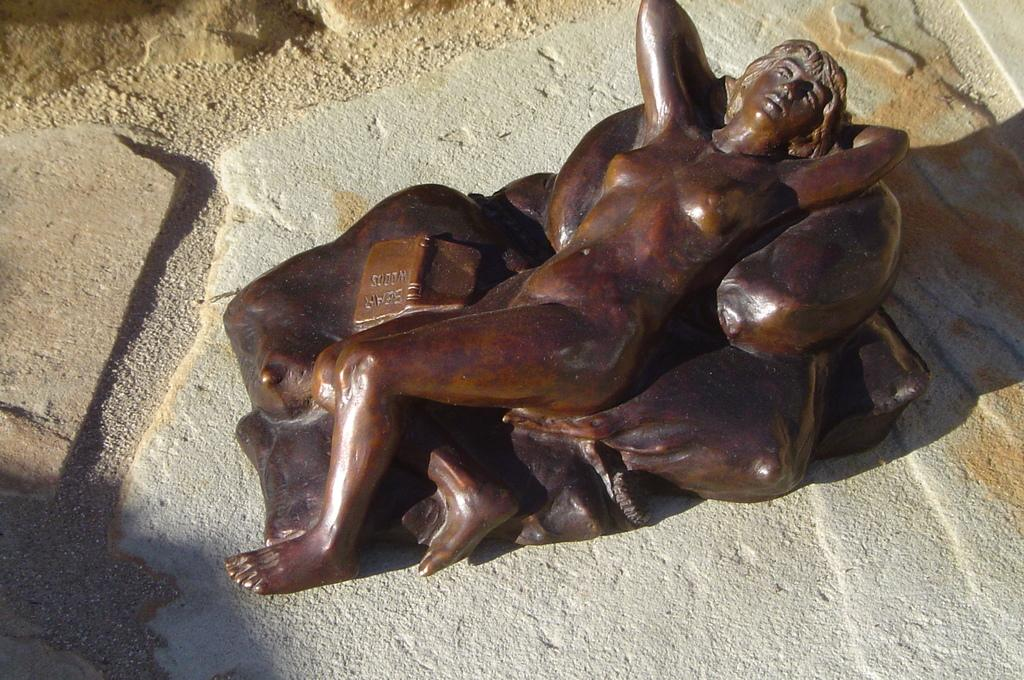What is the main subject of the image? There is a sculpture in the image. How many mice are holding hands in the advertisement in the image? There is no advertisement or mice holding hands present in the image; it features a sculpture. 